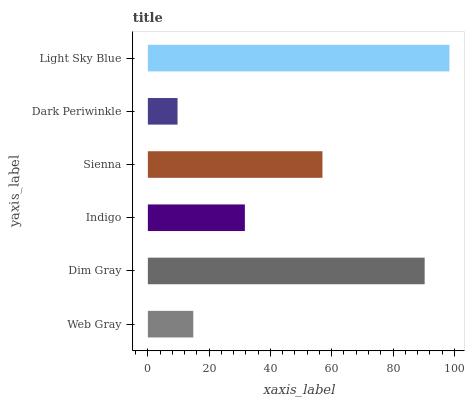Is Dark Periwinkle the minimum?
Answer yes or no. Yes. Is Light Sky Blue the maximum?
Answer yes or no. Yes. Is Dim Gray the minimum?
Answer yes or no. No. Is Dim Gray the maximum?
Answer yes or no. No. Is Dim Gray greater than Web Gray?
Answer yes or no. Yes. Is Web Gray less than Dim Gray?
Answer yes or no. Yes. Is Web Gray greater than Dim Gray?
Answer yes or no. No. Is Dim Gray less than Web Gray?
Answer yes or no. No. Is Sienna the high median?
Answer yes or no. Yes. Is Indigo the low median?
Answer yes or no. Yes. Is Dark Periwinkle the high median?
Answer yes or no. No. Is Dim Gray the low median?
Answer yes or no. No. 